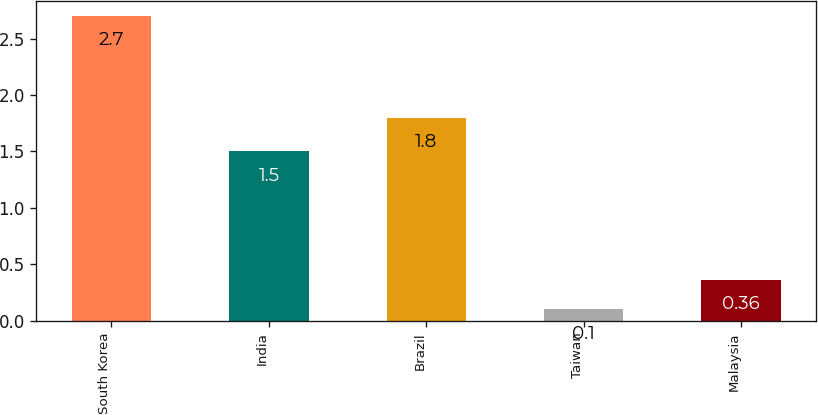<chart> <loc_0><loc_0><loc_500><loc_500><bar_chart><fcel>South Korea<fcel>India<fcel>Brazil<fcel>Taiwan<fcel>Malaysia<nl><fcel>2.7<fcel>1.5<fcel>1.8<fcel>0.1<fcel>0.36<nl></chart> 